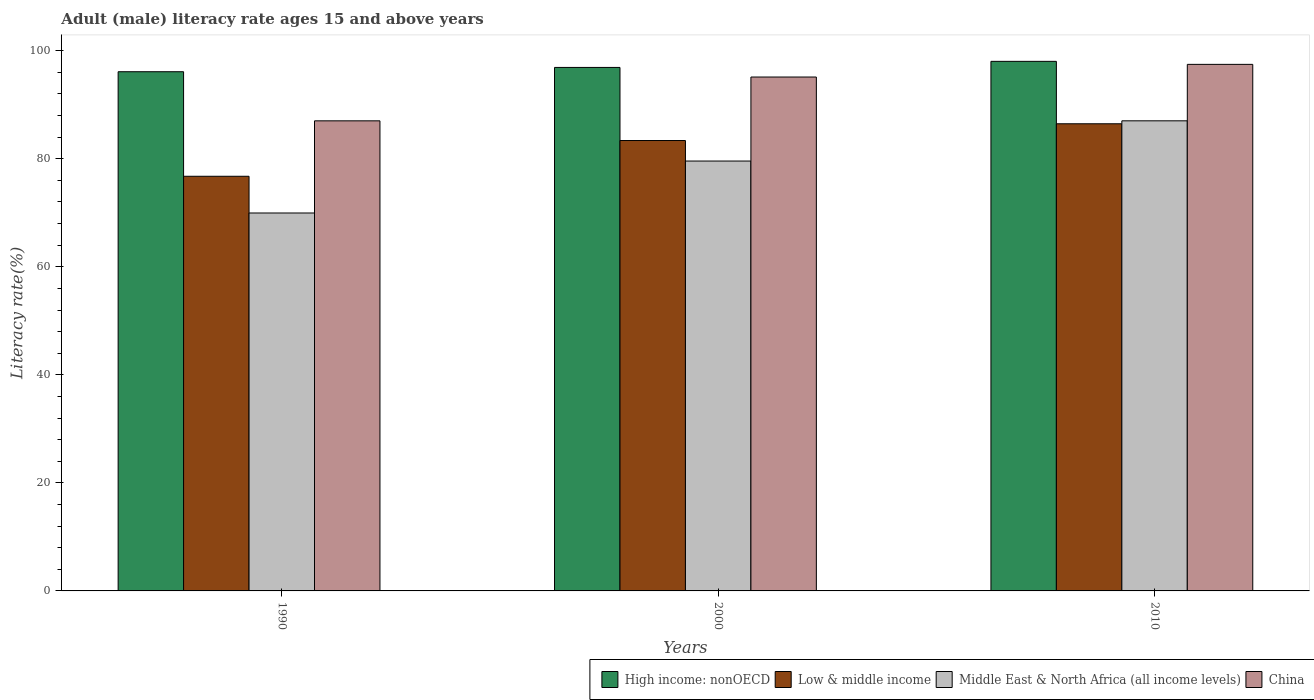How many different coloured bars are there?
Offer a terse response. 4. How many bars are there on the 2nd tick from the right?
Ensure brevity in your answer.  4. In how many cases, is the number of bars for a given year not equal to the number of legend labels?
Provide a short and direct response. 0. What is the adult male literacy rate in China in 2010?
Keep it short and to the point. 97.48. Across all years, what is the maximum adult male literacy rate in China?
Make the answer very short. 97.48. Across all years, what is the minimum adult male literacy rate in China?
Ensure brevity in your answer.  87.02. In which year was the adult male literacy rate in Middle East & North Africa (all income levels) maximum?
Make the answer very short. 2010. What is the total adult male literacy rate in Middle East & North Africa (all income levels) in the graph?
Ensure brevity in your answer.  236.58. What is the difference between the adult male literacy rate in Middle East & North Africa (all income levels) in 1990 and that in 2000?
Your answer should be compact. -9.62. What is the difference between the adult male literacy rate in China in 2000 and the adult male literacy rate in Low & middle income in 1990?
Offer a very short reply. 18.37. What is the average adult male literacy rate in High income: nonOECD per year?
Make the answer very short. 97.02. In the year 2010, what is the difference between the adult male literacy rate in China and adult male literacy rate in Middle East & North Africa (all income levels)?
Your answer should be very brief. 10.45. In how many years, is the adult male literacy rate in China greater than 44 %?
Give a very brief answer. 3. What is the ratio of the adult male literacy rate in High income: nonOECD in 1990 to that in 2010?
Your answer should be very brief. 0.98. Is the adult male literacy rate in China in 2000 less than that in 2010?
Make the answer very short. Yes. Is the difference between the adult male literacy rate in China in 2000 and 2010 greater than the difference between the adult male literacy rate in Middle East & North Africa (all income levels) in 2000 and 2010?
Give a very brief answer. Yes. What is the difference between the highest and the second highest adult male literacy rate in High income: nonOECD?
Your response must be concise. 1.12. What is the difference between the highest and the lowest adult male literacy rate in Middle East & North Africa (all income levels)?
Give a very brief answer. 17.06. In how many years, is the adult male literacy rate in High income: nonOECD greater than the average adult male literacy rate in High income: nonOECD taken over all years?
Your answer should be very brief. 1. Is the sum of the adult male literacy rate in China in 1990 and 2010 greater than the maximum adult male literacy rate in Middle East & North Africa (all income levels) across all years?
Offer a terse response. Yes. What does the 4th bar from the left in 2010 represents?
Your response must be concise. China. What does the 4th bar from the right in 1990 represents?
Your answer should be compact. High income: nonOECD. What is the difference between two consecutive major ticks on the Y-axis?
Give a very brief answer. 20. Are the values on the major ticks of Y-axis written in scientific E-notation?
Offer a terse response. No. Does the graph contain grids?
Offer a very short reply. No. Where does the legend appear in the graph?
Keep it short and to the point. Bottom right. How many legend labels are there?
Make the answer very short. 4. What is the title of the graph?
Keep it short and to the point. Adult (male) literacy rate ages 15 and above years. Does "Arab World" appear as one of the legend labels in the graph?
Make the answer very short. No. What is the label or title of the X-axis?
Your answer should be very brief. Years. What is the label or title of the Y-axis?
Give a very brief answer. Literacy rate(%). What is the Literacy rate(%) in High income: nonOECD in 1990?
Offer a terse response. 96.12. What is the Literacy rate(%) in Low & middle income in 1990?
Provide a succinct answer. 76.76. What is the Literacy rate(%) in Middle East & North Africa (all income levels) in 1990?
Make the answer very short. 69.96. What is the Literacy rate(%) in China in 1990?
Your answer should be compact. 87.02. What is the Literacy rate(%) in High income: nonOECD in 2000?
Keep it short and to the point. 96.91. What is the Literacy rate(%) in Low & middle income in 2000?
Give a very brief answer. 83.38. What is the Literacy rate(%) in Middle East & North Africa (all income levels) in 2000?
Provide a short and direct response. 79.58. What is the Literacy rate(%) of China in 2000?
Make the answer very short. 95.14. What is the Literacy rate(%) of High income: nonOECD in 2010?
Provide a short and direct response. 98.04. What is the Literacy rate(%) in Low & middle income in 2010?
Make the answer very short. 86.48. What is the Literacy rate(%) in Middle East & North Africa (all income levels) in 2010?
Your response must be concise. 87.03. What is the Literacy rate(%) of China in 2010?
Keep it short and to the point. 97.48. Across all years, what is the maximum Literacy rate(%) in High income: nonOECD?
Your response must be concise. 98.04. Across all years, what is the maximum Literacy rate(%) in Low & middle income?
Your answer should be compact. 86.48. Across all years, what is the maximum Literacy rate(%) in Middle East & North Africa (all income levels)?
Your response must be concise. 87.03. Across all years, what is the maximum Literacy rate(%) in China?
Keep it short and to the point. 97.48. Across all years, what is the minimum Literacy rate(%) in High income: nonOECD?
Provide a short and direct response. 96.12. Across all years, what is the minimum Literacy rate(%) in Low & middle income?
Offer a terse response. 76.76. Across all years, what is the minimum Literacy rate(%) of Middle East & North Africa (all income levels)?
Provide a succinct answer. 69.96. Across all years, what is the minimum Literacy rate(%) in China?
Your response must be concise. 87.02. What is the total Literacy rate(%) in High income: nonOECD in the graph?
Your response must be concise. 291.07. What is the total Literacy rate(%) of Low & middle income in the graph?
Your answer should be compact. 246.63. What is the total Literacy rate(%) of Middle East & North Africa (all income levels) in the graph?
Your answer should be very brief. 236.58. What is the total Literacy rate(%) of China in the graph?
Provide a short and direct response. 279.64. What is the difference between the Literacy rate(%) of High income: nonOECD in 1990 and that in 2000?
Provide a succinct answer. -0.8. What is the difference between the Literacy rate(%) in Low & middle income in 1990 and that in 2000?
Provide a succinct answer. -6.62. What is the difference between the Literacy rate(%) of Middle East & North Africa (all income levels) in 1990 and that in 2000?
Make the answer very short. -9.62. What is the difference between the Literacy rate(%) in China in 1990 and that in 2000?
Your answer should be very brief. -8.11. What is the difference between the Literacy rate(%) in High income: nonOECD in 1990 and that in 2010?
Keep it short and to the point. -1.92. What is the difference between the Literacy rate(%) in Low & middle income in 1990 and that in 2010?
Your answer should be very brief. -9.72. What is the difference between the Literacy rate(%) in Middle East & North Africa (all income levels) in 1990 and that in 2010?
Provide a short and direct response. -17.06. What is the difference between the Literacy rate(%) in China in 1990 and that in 2010?
Offer a terse response. -10.45. What is the difference between the Literacy rate(%) in High income: nonOECD in 2000 and that in 2010?
Your response must be concise. -1.12. What is the difference between the Literacy rate(%) in Low & middle income in 2000 and that in 2010?
Your response must be concise. -3.1. What is the difference between the Literacy rate(%) in Middle East & North Africa (all income levels) in 2000 and that in 2010?
Give a very brief answer. -7.45. What is the difference between the Literacy rate(%) of China in 2000 and that in 2010?
Your response must be concise. -2.34. What is the difference between the Literacy rate(%) of High income: nonOECD in 1990 and the Literacy rate(%) of Low & middle income in 2000?
Keep it short and to the point. 12.74. What is the difference between the Literacy rate(%) of High income: nonOECD in 1990 and the Literacy rate(%) of Middle East & North Africa (all income levels) in 2000?
Provide a short and direct response. 16.53. What is the difference between the Literacy rate(%) in High income: nonOECD in 1990 and the Literacy rate(%) in China in 2000?
Offer a very short reply. 0.98. What is the difference between the Literacy rate(%) in Low & middle income in 1990 and the Literacy rate(%) in Middle East & North Africa (all income levels) in 2000?
Keep it short and to the point. -2.82. What is the difference between the Literacy rate(%) of Low & middle income in 1990 and the Literacy rate(%) of China in 2000?
Your response must be concise. -18.37. What is the difference between the Literacy rate(%) of Middle East & North Africa (all income levels) in 1990 and the Literacy rate(%) of China in 2000?
Give a very brief answer. -25.17. What is the difference between the Literacy rate(%) of High income: nonOECD in 1990 and the Literacy rate(%) of Low & middle income in 2010?
Keep it short and to the point. 9.64. What is the difference between the Literacy rate(%) in High income: nonOECD in 1990 and the Literacy rate(%) in Middle East & North Africa (all income levels) in 2010?
Give a very brief answer. 9.09. What is the difference between the Literacy rate(%) of High income: nonOECD in 1990 and the Literacy rate(%) of China in 2010?
Provide a succinct answer. -1.36. What is the difference between the Literacy rate(%) of Low & middle income in 1990 and the Literacy rate(%) of Middle East & North Africa (all income levels) in 2010?
Your answer should be compact. -10.27. What is the difference between the Literacy rate(%) of Low & middle income in 1990 and the Literacy rate(%) of China in 2010?
Ensure brevity in your answer.  -20.72. What is the difference between the Literacy rate(%) in Middle East & North Africa (all income levels) in 1990 and the Literacy rate(%) in China in 2010?
Give a very brief answer. -27.51. What is the difference between the Literacy rate(%) in High income: nonOECD in 2000 and the Literacy rate(%) in Low & middle income in 2010?
Your answer should be very brief. 10.43. What is the difference between the Literacy rate(%) of High income: nonOECD in 2000 and the Literacy rate(%) of Middle East & North Africa (all income levels) in 2010?
Your response must be concise. 9.88. What is the difference between the Literacy rate(%) of High income: nonOECD in 2000 and the Literacy rate(%) of China in 2010?
Offer a very short reply. -0.57. What is the difference between the Literacy rate(%) in Low & middle income in 2000 and the Literacy rate(%) in Middle East & North Africa (all income levels) in 2010?
Offer a very short reply. -3.65. What is the difference between the Literacy rate(%) in Low & middle income in 2000 and the Literacy rate(%) in China in 2010?
Your answer should be compact. -14.1. What is the difference between the Literacy rate(%) of Middle East & North Africa (all income levels) in 2000 and the Literacy rate(%) of China in 2010?
Offer a terse response. -17.9. What is the average Literacy rate(%) of High income: nonOECD per year?
Ensure brevity in your answer.  97.02. What is the average Literacy rate(%) in Low & middle income per year?
Your answer should be very brief. 82.21. What is the average Literacy rate(%) in Middle East & North Africa (all income levels) per year?
Provide a succinct answer. 78.86. What is the average Literacy rate(%) in China per year?
Provide a succinct answer. 93.21. In the year 1990, what is the difference between the Literacy rate(%) in High income: nonOECD and Literacy rate(%) in Low & middle income?
Offer a terse response. 19.35. In the year 1990, what is the difference between the Literacy rate(%) of High income: nonOECD and Literacy rate(%) of Middle East & North Africa (all income levels)?
Your response must be concise. 26.15. In the year 1990, what is the difference between the Literacy rate(%) of High income: nonOECD and Literacy rate(%) of China?
Offer a very short reply. 9.09. In the year 1990, what is the difference between the Literacy rate(%) of Low & middle income and Literacy rate(%) of Middle East & North Africa (all income levels)?
Offer a very short reply. 6.8. In the year 1990, what is the difference between the Literacy rate(%) in Low & middle income and Literacy rate(%) in China?
Offer a very short reply. -10.26. In the year 1990, what is the difference between the Literacy rate(%) of Middle East & North Africa (all income levels) and Literacy rate(%) of China?
Give a very brief answer. -17.06. In the year 2000, what is the difference between the Literacy rate(%) in High income: nonOECD and Literacy rate(%) in Low & middle income?
Offer a very short reply. 13.53. In the year 2000, what is the difference between the Literacy rate(%) in High income: nonOECD and Literacy rate(%) in Middle East & North Africa (all income levels)?
Your answer should be compact. 17.33. In the year 2000, what is the difference between the Literacy rate(%) of High income: nonOECD and Literacy rate(%) of China?
Make the answer very short. 1.78. In the year 2000, what is the difference between the Literacy rate(%) in Low & middle income and Literacy rate(%) in Middle East & North Africa (all income levels)?
Give a very brief answer. 3.8. In the year 2000, what is the difference between the Literacy rate(%) of Low & middle income and Literacy rate(%) of China?
Ensure brevity in your answer.  -11.75. In the year 2000, what is the difference between the Literacy rate(%) in Middle East & North Africa (all income levels) and Literacy rate(%) in China?
Your answer should be very brief. -15.55. In the year 2010, what is the difference between the Literacy rate(%) in High income: nonOECD and Literacy rate(%) in Low & middle income?
Your response must be concise. 11.56. In the year 2010, what is the difference between the Literacy rate(%) of High income: nonOECD and Literacy rate(%) of Middle East & North Africa (all income levels)?
Offer a terse response. 11.01. In the year 2010, what is the difference between the Literacy rate(%) of High income: nonOECD and Literacy rate(%) of China?
Make the answer very short. 0.56. In the year 2010, what is the difference between the Literacy rate(%) of Low & middle income and Literacy rate(%) of Middle East & North Africa (all income levels)?
Ensure brevity in your answer.  -0.55. In the year 2010, what is the difference between the Literacy rate(%) in Low & middle income and Literacy rate(%) in China?
Provide a short and direct response. -11. In the year 2010, what is the difference between the Literacy rate(%) of Middle East & North Africa (all income levels) and Literacy rate(%) of China?
Provide a succinct answer. -10.45. What is the ratio of the Literacy rate(%) in High income: nonOECD in 1990 to that in 2000?
Offer a terse response. 0.99. What is the ratio of the Literacy rate(%) in Low & middle income in 1990 to that in 2000?
Provide a short and direct response. 0.92. What is the ratio of the Literacy rate(%) of Middle East & North Africa (all income levels) in 1990 to that in 2000?
Your answer should be very brief. 0.88. What is the ratio of the Literacy rate(%) of China in 1990 to that in 2000?
Provide a succinct answer. 0.91. What is the ratio of the Literacy rate(%) of High income: nonOECD in 1990 to that in 2010?
Provide a succinct answer. 0.98. What is the ratio of the Literacy rate(%) of Low & middle income in 1990 to that in 2010?
Offer a very short reply. 0.89. What is the ratio of the Literacy rate(%) of Middle East & North Africa (all income levels) in 1990 to that in 2010?
Your response must be concise. 0.8. What is the ratio of the Literacy rate(%) of China in 1990 to that in 2010?
Offer a terse response. 0.89. What is the ratio of the Literacy rate(%) of Low & middle income in 2000 to that in 2010?
Make the answer very short. 0.96. What is the ratio of the Literacy rate(%) of Middle East & North Africa (all income levels) in 2000 to that in 2010?
Make the answer very short. 0.91. What is the ratio of the Literacy rate(%) of China in 2000 to that in 2010?
Offer a terse response. 0.98. What is the difference between the highest and the second highest Literacy rate(%) in High income: nonOECD?
Provide a short and direct response. 1.12. What is the difference between the highest and the second highest Literacy rate(%) of Low & middle income?
Offer a terse response. 3.1. What is the difference between the highest and the second highest Literacy rate(%) in Middle East & North Africa (all income levels)?
Offer a very short reply. 7.45. What is the difference between the highest and the second highest Literacy rate(%) in China?
Make the answer very short. 2.34. What is the difference between the highest and the lowest Literacy rate(%) of High income: nonOECD?
Give a very brief answer. 1.92. What is the difference between the highest and the lowest Literacy rate(%) in Low & middle income?
Your response must be concise. 9.72. What is the difference between the highest and the lowest Literacy rate(%) in Middle East & North Africa (all income levels)?
Make the answer very short. 17.06. What is the difference between the highest and the lowest Literacy rate(%) of China?
Ensure brevity in your answer.  10.45. 